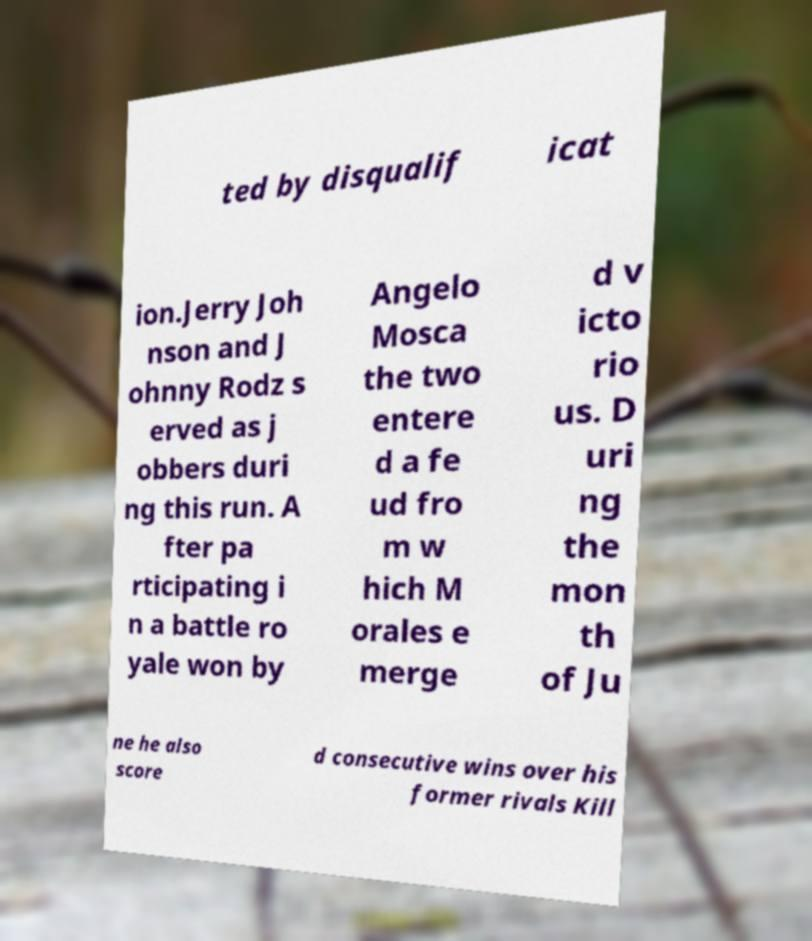Can you read and provide the text displayed in the image?This photo seems to have some interesting text. Can you extract and type it out for me? ted by disqualif icat ion.Jerry Joh nson and J ohnny Rodz s erved as j obbers duri ng this run. A fter pa rticipating i n a battle ro yale won by Angelo Mosca the two entere d a fe ud fro m w hich M orales e merge d v icto rio us. D uri ng the mon th of Ju ne he also score d consecutive wins over his former rivals Kill 